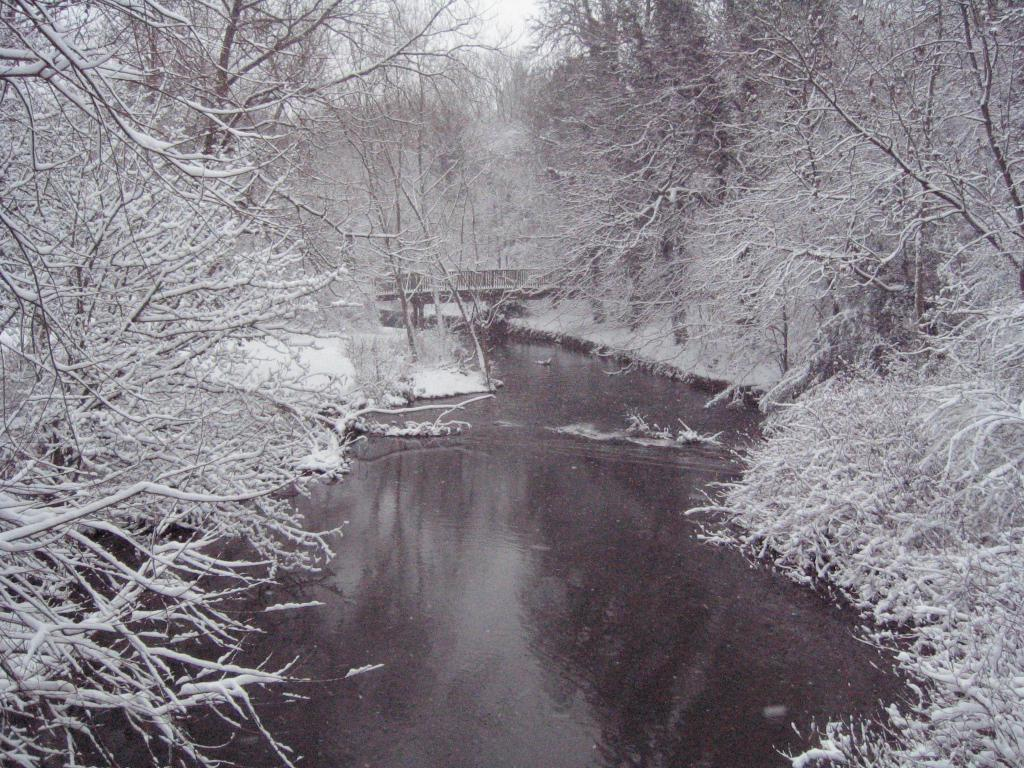What type of vegetation is present on both sides of the image? There are trees on both the right and left sides of the image. What natural feature can be seen at the bottom of the image? There is a river at the bottom of the image. Is there a beginner farmer standing near the river in the image? There is no information about a farmer or any people in the image, so we cannot determine if there is a beginner farmer present. 